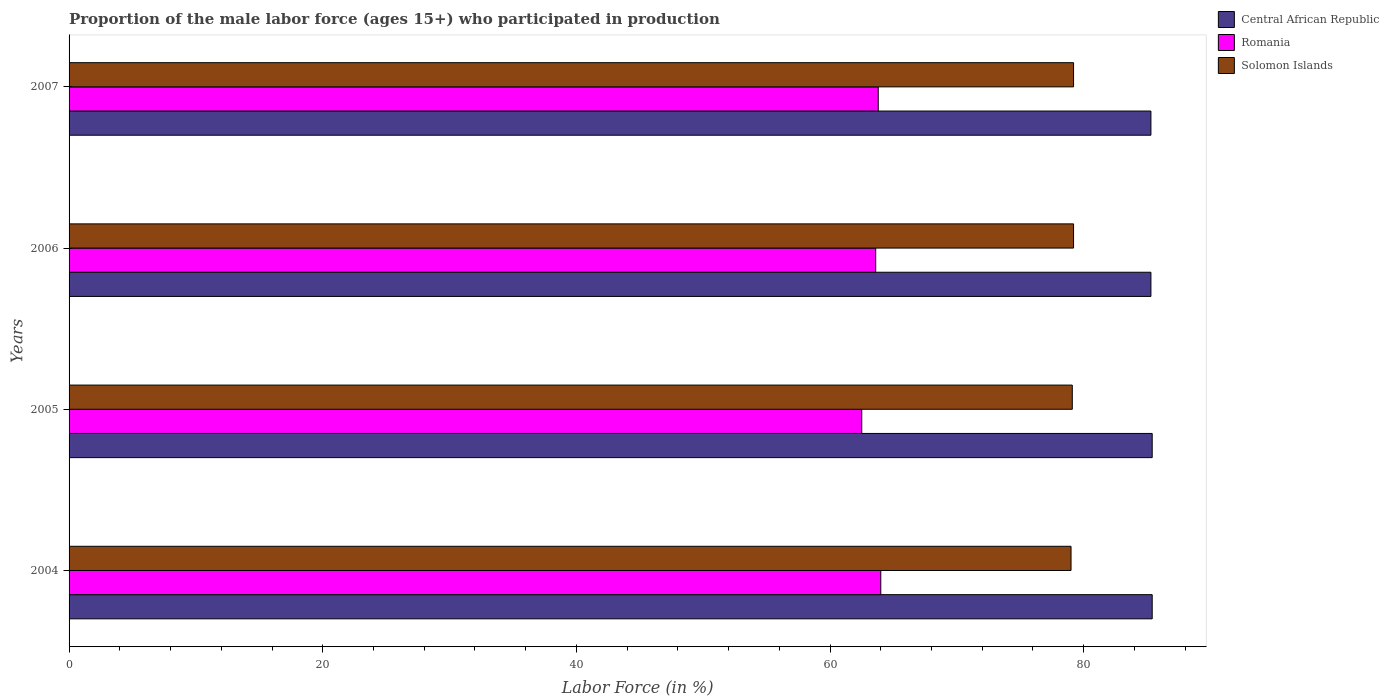How many different coloured bars are there?
Keep it short and to the point. 3. Are the number of bars per tick equal to the number of legend labels?
Give a very brief answer. Yes. How many bars are there on the 1st tick from the top?
Make the answer very short. 3. How many bars are there on the 2nd tick from the bottom?
Your answer should be very brief. 3. What is the label of the 2nd group of bars from the top?
Ensure brevity in your answer.  2006. What is the proportion of the male labor force who participated in production in Central African Republic in 2006?
Give a very brief answer. 85.3. Across all years, what is the maximum proportion of the male labor force who participated in production in Romania?
Give a very brief answer. 64. Across all years, what is the minimum proportion of the male labor force who participated in production in Solomon Islands?
Provide a succinct answer. 79. In which year was the proportion of the male labor force who participated in production in Solomon Islands minimum?
Your answer should be very brief. 2004. What is the total proportion of the male labor force who participated in production in Central African Republic in the graph?
Your response must be concise. 341.4. What is the difference between the proportion of the male labor force who participated in production in Solomon Islands in 2004 and that in 2006?
Offer a very short reply. -0.2. What is the difference between the proportion of the male labor force who participated in production in Central African Republic in 2004 and the proportion of the male labor force who participated in production in Romania in 2006?
Give a very brief answer. 21.8. What is the average proportion of the male labor force who participated in production in Solomon Islands per year?
Your response must be concise. 79.12. In the year 2006, what is the difference between the proportion of the male labor force who participated in production in Central African Republic and proportion of the male labor force who participated in production in Solomon Islands?
Offer a terse response. 6.1. In how many years, is the proportion of the male labor force who participated in production in Central African Republic greater than 28 %?
Provide a short and direct response. 4. What is the ratio of the proportion of the male labor force who participated in production in Romania in 2005 to that in 2007?
Provide a succinct answer. 0.98. Is the difference between the proportion of the male labor force who participated in production in Central African Republic in 2005 and 2007 greater than the difference between the proportion of the male labor force who participated in production in Solomon Islands in 2005 and 2007?
Provide a short and direct response. Yes. What is the difference between the highest and the lowest proportion of the male labor force who participated in production in Solomon Islands?
Provide a succinct answer. 0.2. Is the sum of the proportion of the male labor force who participated in production in Romania in 2004 and 2007 greater than the maximum proportion of the male labor force who participated in production in Central African Republic across all years?
Give a very brief answer. Yes. What does the 3rd bar from the top in 2007 represents?
Your answer should be very brief. Central African Republic. What does the 3rd bar from the bottom in 2006 represents?
Your answer should be compact. Solomon Islands. Is it the case that in every year, the sum of the proportion of the male labor force who participated in production in Romania and proportion of the male labor force who participated in production in Solomon Islands is greater than the proportion of the male labor force who participated in production in Central African Republic?
Give a very brief answer. Yes. How many years are there in the graph?
Offer a very short reply. 4. Does the graph contain any zero values?
Offer a very short reply. No. Where does the legend appear in the graph?
Ensure brevity in your answer.  Top right. What is the title of the graph?
Provide a succinct answer. Proportion of the male labor force (ages 15+) who participated in production. Does "United Kingdom" appear as one of the legend labels in the graph?
Provide a short and direct response. No. What is the label or title of the X-axis?
Give a very brief answer. Labor Force (in %). What is the Labor Force (in %) in Central African Republic in 2004?
Provide a succinct answer. 85.4. What is the Labor Force (in %) of Romania in 2004?
Your answer should be compact. 64. What is the Labor Force (in %) of Solomon Islands in 2004?
Provide a succinct answer. 79. What is the Labor Force (in %) in Central African Republic in 2005?
Give a very brief answer. 85.4. What is the Labor Force (in %) of Romania in 2005?
Offer a very short reply. 62.5. What is the Labor Force (in %) in Solomon Islands in 2005?
Your answer should be compact. 79.1. What is the Labor Force (in %) in Central African Republic in 2006?
Make the answer very short. 85.3. What is the Labor Force (in %) in Romania in 2006?
Provide a short and direct response. 63.6. What is the Labor Force (in %) of Solomon Islands in 2006?
Ensure brevity in your answer.  79.2. What is the Labor Force (in %) of Central African Republic in 2007?
Offer a very short reply. 85.3. What is the Labor Force (in %) in Romania in 2007?
Make the answer very short. 63.8. What is the Labor Force (in %) of Solomon Islands in 2007?
Your answer should be very brief. 79.2. Across all years, what is the maximum Labor Force (in %) of Central African Republic?
Give a very brief answer. 85.4. Across all years, what is the maximum Labor Force (in %) of Romania?
Your response must be concise. 64. Across all years, what is the maximum Labor Force (in %) of Solomon Islands?
Provide a short and direct response. 79.2. Across all years, what is the minimum Labor Force (in %) in Central African Republic?
Your answer should be compact. 85.3. Across all years, what is the minimum Labor Force (in %) in Romania?
Provide a short and direct response. 62.5. Across all years, what is the minimum Labor Force (in %) in Solomon Islands?
Make the answer very short. 79. What is the total Labor Force (in %) in Central African Republic in the graph?
Offer a terse response. 341.4. What is the total Labor Force (in %) of Romania in the graph?
Give a very brief answer. 253.9. What is the total Labor Force (in %) in Solomon Islands in the graph?
Make the answer very short. 316.5. What is the difference between the Labor Force (in %) in Central African Republic in 2004 and that in 2005?
Your response must be concise. 0. What is the difference between the Labor Force (in %) of Romania in 2004 and that in 2005?
Offer a terse response. 1.5. What is the difference between the Labor Force (in %) in Central African Republic in 2004 and that in 2006?
Your response must be concise. 0.1. What is the difference between the Labor Force (in %) of Solomon Islands in 2004 and that in 2006?
Your response must be concise. -0.2. What is the difference between the Labor Force (in %) of Romania in 2004 and that in 2007?
Your answer should be compact. 0.2. What is the difference between the Labor Force (in %) of Central African Republic in 2005 and that in 2006?
Your response must be concise. 0.1. What is the difference between the Labor Force (in %) of Solomon Islands in 2005 and that in 2007?
Make the answer very short. -0.1. What is the difference between the Labor Force (in %) in Central African Republic in 2006 and that in 2007?
Offer a terse response. 0. What is the difference between the Labor Force (in %) in Romania in 2006 and that in 2007?
Offer a very short reply. -0.2. What is the difference between the Labor Force (in %) of Solomon Islands in 2006 and that in 2007?
Keep it short and to the point. 0. What is the difference between the Labor Force (in %) of Central African Republic in 2004 and the Labor Force (in %) of Romania in 2005?
Ensure brevity in your answer.  22.9. What is the difference between the Labor Force (in %) of Central African Republic in 2004 and the Labor Force (in %) of Solomon Islands in 2005?
Your answer should be compact. 6.3. What is the difference between the Labor Force (in %) in Romania in 2004 and the Labor Force (in %) in Solomon Islands in 2005?
Offer a terse response. -15.1. What is the difference between the Labor Force (in %) of Central African Republic in 2004 and the Labor Force (in %) of Romania in 2006?
Provide a succinct answer. 21.8. What is the difference between the Labor Force (in %) in Central African Republic in 2004 and the Labor Force (in %) in Solomon Islands in 2006?
Your answer should be compact. 6.2. What is the difference between the Labor Force (in %) in Romania in 2004 and the Labor Force (in %) in Solomon Islands in 2006?
Your answer should be very brief. -15.2. What is the difference between the Labor Force (in %) in Central African Republic in 2004 and the Labor Force (in %) in Romania in 2007?
Offer a terse response. 21.6. What is the difference between the Labor Force (in %) in Romania in 2004 and the Labor Force (in %) in Solomon Islands in 2007?
Provide a short and direct response. -15.2. What is the difference between the Labor Force (in %) in Central African Republic in 2005 and the Labor Force (in %) in Romania in 2006?
Your answer should be compact. 21.8. What is the difference between the Labor Force (in %) of Romania in 2005 and the Labor Force (in %) of Solomon Islands in 2006?
Your answer should be compact. -16.7. What is the difference between the Labor Force (in %) in Central African Republic in 2005 and the Labor Force (in %) in Romania in 2007?
Your answer should be very brief. 21.6. What is the difference between the Labor Force (in %) in Central African Republic in 2005 and the Labor Force (in %) in Solomon Islands in 2007?
Your response must be concise. 6.2. What is the difference between the Labor Force (in %) of Romania in 2005 and the Labor Force (in %) of Solomon Islands in 2007?
Make the answer very short. -16.7. What is the difference between the Labor Force (in %) in Central African Republic in 2006 and the Labor Force (in %) in Solomon Islands in 2007?
Your answer should be compact. 6.1. What is the difference between the Labor Force (in %) of Romania in 2006 and the Labor Force (in %) of Solomon Islands in 2007?
Give a very brief answer. -15.6. What is the average Labor Force (in %) in Central African Republic per year?
Keep it short and to the point. 85.35. What is the average Labor Force (in %) in Romania per year?
Provide a succinct answer. 63.48. What is the average Labor Force (in %) of Solomon Islands per year?
Provide a short and direct response. 79.12. In the year 2004, what is the difference between the Labor Force (in %) in Central African Republic and Labor Force (in %) in Romania?
Offer a very short reply. 21.4. In the year 2005, what is the difference between the Labor Force (in %) of Central African Republic and Labor Force (in %) of Romania?
Your answer should be compact. 22.9. In the year 2005, what is the difference between the Labor Force (in %) in Central African Republic and Labor Force (in %) in Solomon Islands?
Your answer should be very brief. 6.3. In the year 2005, what is the difference between the Labor Force (in %) in Romania and Labor Force (in %) in Solomon Islands?
Your response must be concise. -16.6. In the year 2006, what is the difference between the Labor Force (in %) in Central African Republic and Labor Force (in %) in Romania?
Provide a succinct answer. 21.7. In the year 2006, what is the difference between the Labor Force (in %) in Central African Republic and Labor Force (in %) in Solomon Islands?
Provide a short and direct response. 6.1. In the year 2006, what is the difference between the Labor Force (in %) of Romania and Labor Force (in %) of Solomon Islands?
Offer a terse response. -15.6. In the year 2007, what is the difference between the Labor Force (in %) in Central African Republic and Labor Force (in %) in Romania?
Your response must be concise. 21.5. In the year 2007, what is the difference between the Labor Force (in %) of Central African Republic and Labor Force (in %) of Solomon Islands?
Offer a very short reply. 6.1. In the year 2007, what is the difference between the Labor Force (in %) in Romania and Labor Force (in %) in Solomon Islands?
Provide a succinct answer. -15.4. What is the ratio of the Labor Force (in %) in Central African Republic in 2004 to that in 2005?
Offer a very short reply. 1. What is the ratio of the Labor Force (in %) in Central African Republic in 2004 to that in 2006?
Your answer should be compact. 1. What is the ratio of the Labor Force (in %) of Central African Republic in 2004 to that in 2007?
Make the answer very short. 1. What is the ratio of the Labor Force (in %) of Romania in 2005 to that in 2006?
Keep it short and to the point. 0.98. What is the ratio of the Labor Force (in %) of Solomon Islands in 2005 to that in 2006?
Provide a short and direct response. 1. What is the ratio of the Labor Force (in %) of Central African Republic in 2005 to that in 2007?
Keep it short and to the point. 1. What is the ratio of the Labor Force (in %) of Romania in 2005 to that in 2007?
Offer a terse response. 0.98. What is the ratio of the Labor Force (in %) of Central African Republic in 2006 to that in 2007?
Keep it short and to the point. 1. What is the ratio of the Labor Force (in %) of Romania in 2006 to that in 2007?
Provide a succinct answer. 1. What is the difference between the highest and the second highest Labor Force (in %) in Central African Republic?
Provide a succinct answer. 0. What is the difference between the highest and the second highest Labor Force (in %) of Romania?
Your answer should be very brief. 0.2. What is the difference between the highest and the lowest Labor Force (in %) of Romania?
Provide a short and direct response. 1.5. 